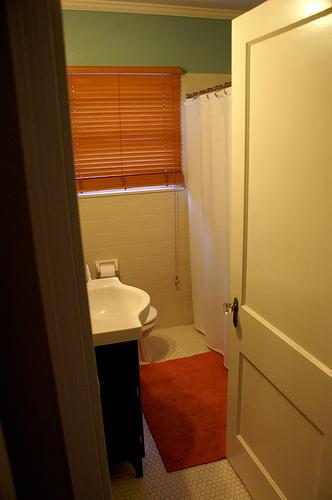What color are the blinds?
Short answer required. Brown. Does the person that lives here like earth tones?
Quick response, please. Yes. Is the door open?
Write a very short answer. Yes. 